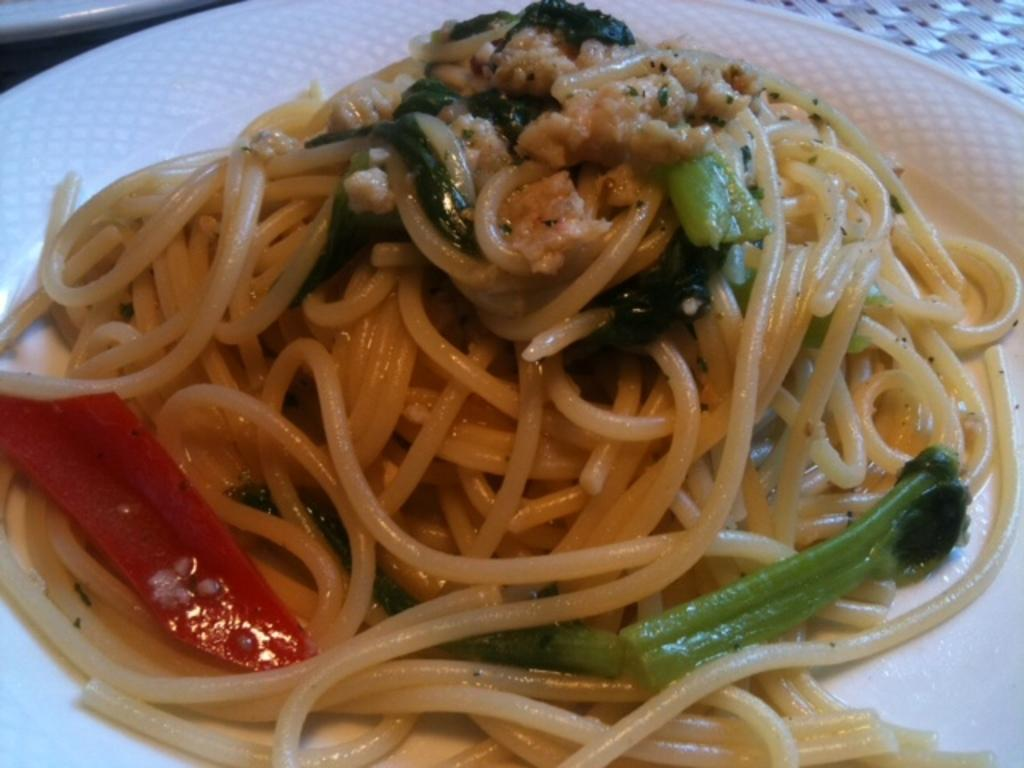What is on the plate that is visible in the image? The plate has noodles and broccoli on it, as well as other food. Where is the plate located in the image? The plate is located in the left top area of the image. What type of comb can be seen in the image? There is no comb present in the image. Is the plate on a shelf in the image? The provided facts do not mention a shelf, so it cannot be determined if the plate is on a shelf. --- Facts: 1. There is a person in the image. 2. The person is wearing a hat. 3. The person is holding a book. 4. The person is sitting on a chair. 5. There is a table in the image. Absurd Topics: bicycle, parrot, ocean Conversation: What is the person in the image doing? The person is sitting on a chair and holding a book. What is the person wearing in the image? The person is wearing a hat. What object is the person holding in the image? The person is holding a book. What piece of furniture is present in the image? There is a table in the image. Reasoning: Let's think step by step in order to produce the conversation. We start by identifying the main subject in the image, which is the person. Then, we expand the conversation to include the person's actions, clothing, and the objects they are holding. Finally, we describe the furniture present in the image. Each question is designed to elicit a specific detail about the image that is known from the provided facts. Absurd Question/Answer: Can you see a parrot sitting on the person's shoulder in the image? There is no parrot present in the image. Is the person riding a bicycle in the image? The provided facts do not mention a bicycle, so it cannot be determined if the person is riding one. --- Facts: 1. There is a car in the image. 2. The car is red. 3. The car has four wheels. 4. The car has a sunroof. 5. The car is parked on the street. Absurd Topics: treehouse, sandcastle, volcano Conversation: What type of vehicle is in the image? There is a car in the image. What color is the car in the image? The car is red. How many wheels does the car have? The car has four wheels. What feature does the car have on its roof? The car has a sunroof. Where is the car located in the image? The car is parked on the street. Reasoning: Let's think step by step in order to produce the conversation 